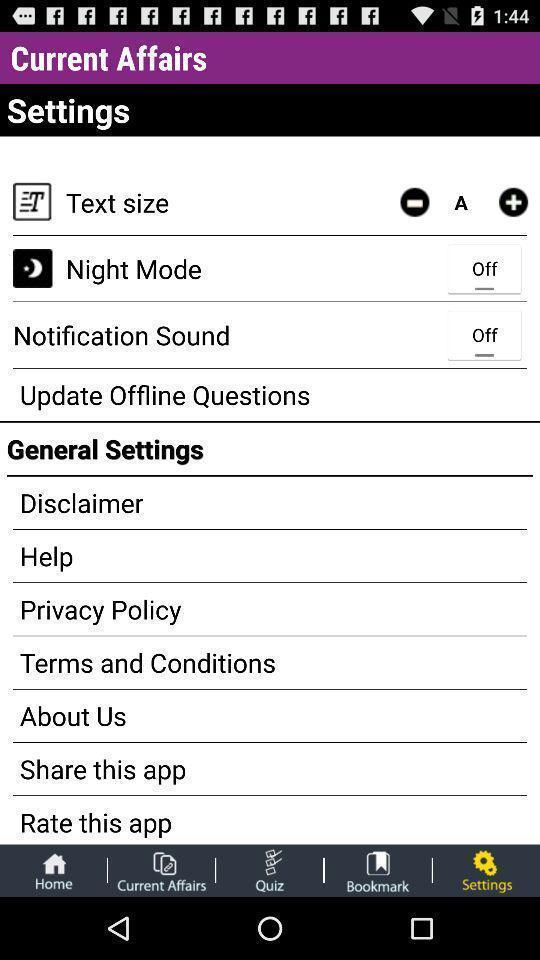Explain the elements present in this screenshot. Settings page. 